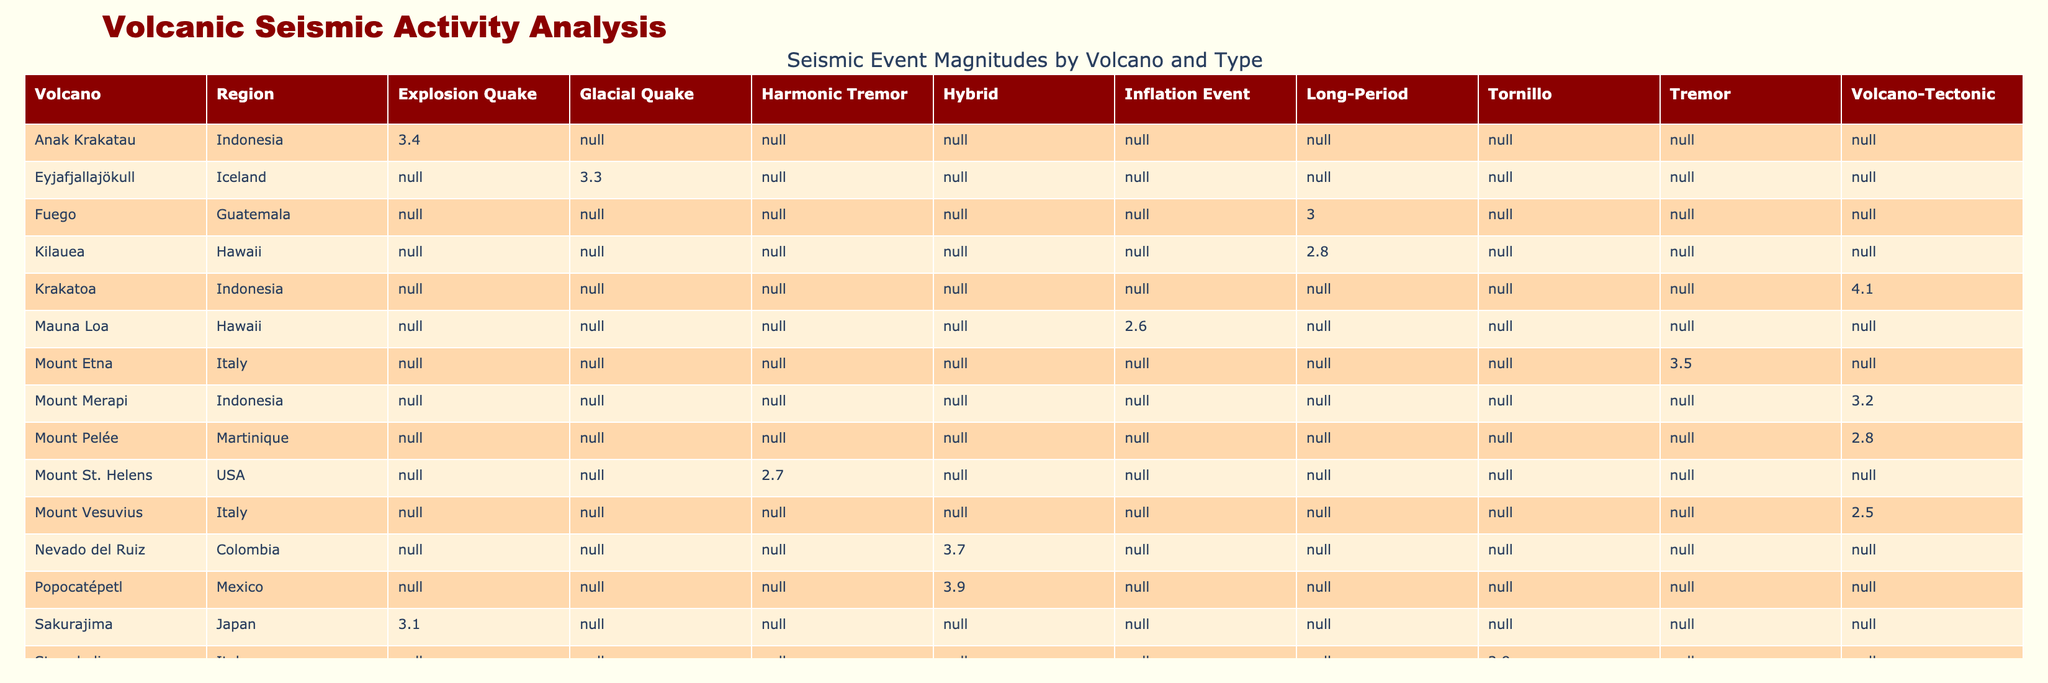What is the maximum magnitude recorded for seismic events associated with Mount Merapi? Referring to the table, Mount Merapi has a recorded magnitude of 3.2 for the Volcano-Tectonic seismic event, which is the only entry for this volcano, hence the maximum is also 3.2
Answer: 3.2 What is the average magnitude of Long-Period events across all volcanoes? For Long-Period events, the recorded magnitudes are 2.8 (Kilauea) and 3.0 (Fuego). Summing these gives 2.8 + 3.0 = 5.8. The number of events is 2, so the average is 5.8/2 = 2.9
Answer: 2.9 Is there any volcanic activity observed for Mount Vesuvius? The table shows that for Mount Vesuvius, the volcanic activity observed is noted as Fumarolic Activity, which implies some level of activity
Answer: Yes Which volcano experienced the deepest seismic event and what was its depth? Reviewing the depths, the deepest event is from Krakatoa, with a depth of 7.2 km, which corresponds to a Volcano-Tectonic event
Answer: 7.2 km Are there any records of hybrid seismic events that have a magnitude greater than 3.5? The table shows two hybrid seismic events: one from Popocatépetl with a magnitude of 3.9 and one from Nevado del Ruiz with a magnitude of 3.7. Both are greater than 3.5
Answer: Yes What is the total number of recorded eruption scales greater than 2 among the listed volcanoes? In the table, eruption scales greater than 2 are found for Popocatépetl (3), Eyjafjallajökull (4), and Nevado del Ruiz (3). Counting them gives a total of 3 entries: thus, the total is 3
Answer: 3 Which volcanic region has the highest average magnitude of seismic events? We calculate the average magnitudes for each region: Indonesia (3.2 and 4.1 average = 3.65), Hawaii (2.8, 2.6 average = 2.7), Italy (3.5, 2.5, 2.9 average = 2.67), Mexico (3.9), Guatemala (3.0), Japan (3.1), Iceland (3.3), Martinique (2.8). Indonesia has the highest average magnitude of 3.65
Answer: Indonesia What volcanic activity was observed at the time of the greatest seismic magnitude? Looking at the table for the highest magnitude recorded, which is 4.1 from Krakatoa, the volcanic activity observed was a Submarine Eruption
Answer: Submarine Eruption How many distinct regions have witnessed eruption scales of 1? Checking the table, Mount Merapi in Indonesia, Mauna Loa in Hawaii, and Mount Pelée in Martinique have an eruption scale of 1. This sums up to 3 distinct regions with scales at this level
Answer: 3 